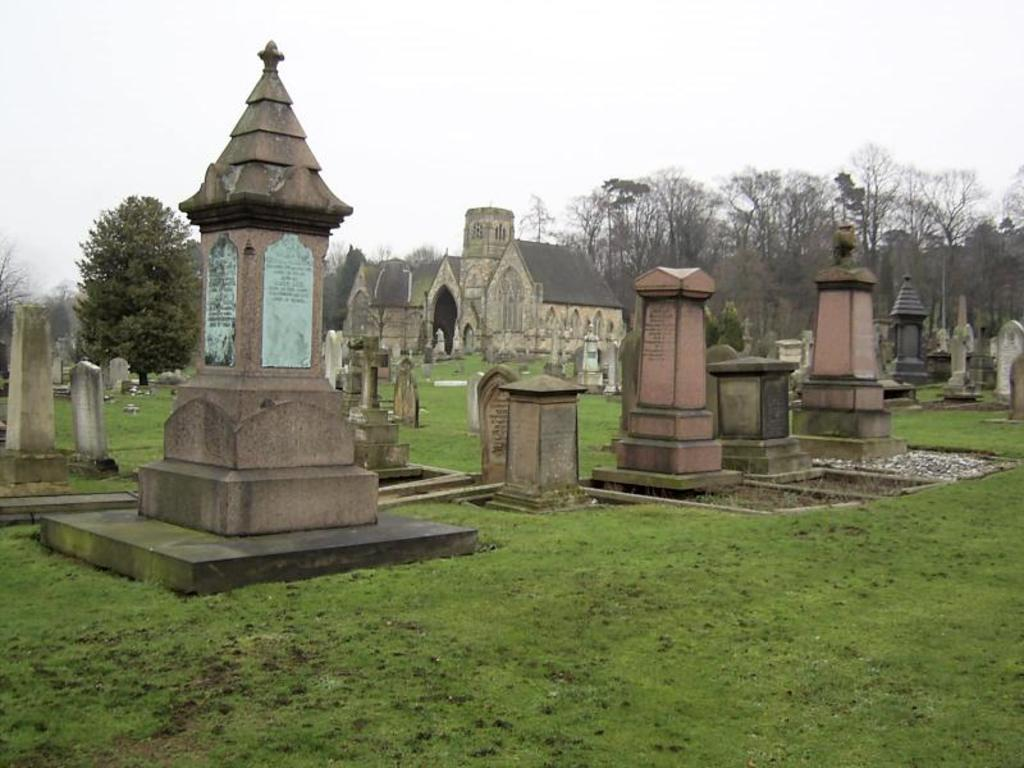What type of structure is visible in the image? There is a building in the image. What other natural elements can be seen in the image? There are trees in the image. What is the purpose of the area depicted in the image? There is a cemetery in the image. What is visible at the top of the image? The sky is visible at the top of the image. What type of ground cover is present at the bottom of the image? Grass is present at the bottom of the image. Where can you find houses for sale in the image? There is no reference to houses for sale in the image; it features a building, trees, a cemetery, the sky, and grass. What type of bait is being used to catch fish in the image? There is no fishing or bait present in the image. 